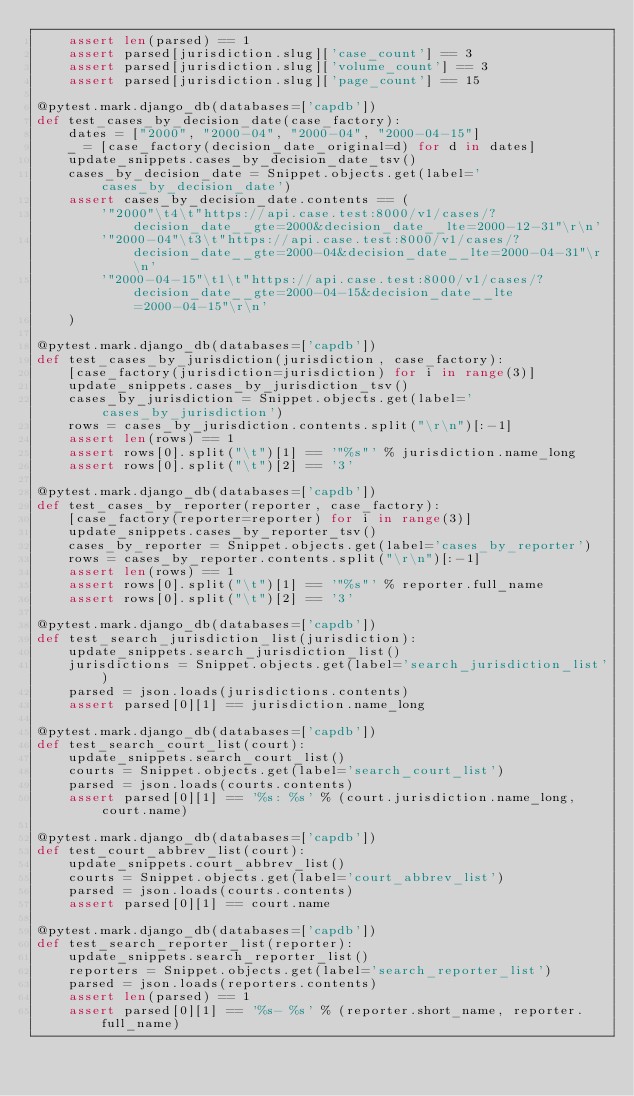<code> <loc_0><loc_0><loc_500><loc_500><_Python_>    assert len(parsed) == 1
    assert parsed[jurisdiction.slug]['case_count'] == 3
    assert parsed[jurisdiction.slug]['volume_count'] == 3
    assert parsed[jurisdiction.slug]['page_count'] == 15

@pytest.mark.django_db(databases=['capdb'])
def test_cases_by_decision_date(case_factory):
    dates = ["2000", "2000-04", "2000-04", "2000-04-15"]
    _ = [case_factory(decision_date_original=d) for d in dates]
    update_snippets.cases_by_decision_date_tsv()
    cases_by_decision_date = Snippet.objects.get(label='cases_by_decision_date')
    assert cases_by_decision_date.contents == (
        '"2000"\t4\t"https://api.case.test:8000/v1/cases/?decision_date__gte=2000&decision_date__lte=2000-12-31"\r\n'
        '"2000-04"\t3\t"https://api.case.test:8000/v1/cases/?decision_date__gte=2000-04&decision_date__lte=2000-04-31"\r\n'
        '"2000-04-15"\t1\t"https://api.case.test:8000/v1/cases/?decision_date__gte=2000-04-15&decision_date__lte=2000-04-15"\r\n'
    )

@pytest.mark.django_db(databases=['capdb'])
def test_cases_by_jurisdiction(jurisdiction, case_factory):
    [case_factory(jurisdiction=jurisdiction) for i in range(3)]
    update_snippets.cases_by_jurisdiction_tsv()
    cases_by_jurisdiction = Snippet.objects.get(label='cases_by_jurisdiction')
    rows = cases_by_jurisdiction.contents.split("\r\n")[:-1]
    assert len(rows) == 1
    assert rows[0].split("\t")[1] == '"%s"' % jurisdiction.name_long
    assert rows[0].split("\t")[2] == '3'

@pytest.mark.django_db(databases=['capdb'])
def test_cases_by_reporter(reporter, case_factory):
    [case_factory(reporter=reporter) for i in range(3)]
    update_snippets.cases_by_reporter_tsv()
    cases_by_reporter = Snippet.objects.get(label='cases_by_reporter')
    rows = cases_by_reporter.contents.split("\r\n")[:-1]
    assert len(rows) == 1
    assert rows[0].split("\t")[1] == '"%s"' % reporter.full_name
    assert rows[0].split("\t")[2] == '3'

@pytest.mark.django_db(databases=['capdb'])
def test_search_jurisdiction_list(jurisdiction):
    update_snippets.search_jurisdiction_list()
    jurisdictions = Snippet.objects.get(label='search_jurisdiction_list')
    parsed = json.loads(jurisdictions.contents)
    assert parsed[0][1] == jurisdiction.name_long

@pytest.mark.django_db(databases=['capdb'])
def test_search_court_list(court):
    update_snippets.search_court_list()
    courts = Snippet.objects.get(label='search_court_list')
    parsed = json.loads(courts.contents)
    assert parsed[0][1] == '%s: %s' % (court.jurisdiction.name_long, court.name)

@pytest.mark.django_db(databases=['capdb'])
def test_court_abbrev_list(court):
    update_snippets.court_abbrev_list()
    courts = Snippet.objects.get(label='court_abbrev_list')
    parsed = json.loads(courts.contents)
    assert parsed[0][1] == court.name

@pytest.mark.django_db(databases=['capdb'])
def test_search_reporter_list(reporter):
    update_snippets.search_reporter_list()
    reporters = Snippet.objects.get(label='search_reporter_list')
    parsed = json.loads(reporters.contents)
    assert len(parsed) == 1
    assert parsed[0][1] == '%s- %s' % (reporter.short_name, reporter.full_name)
</code> 